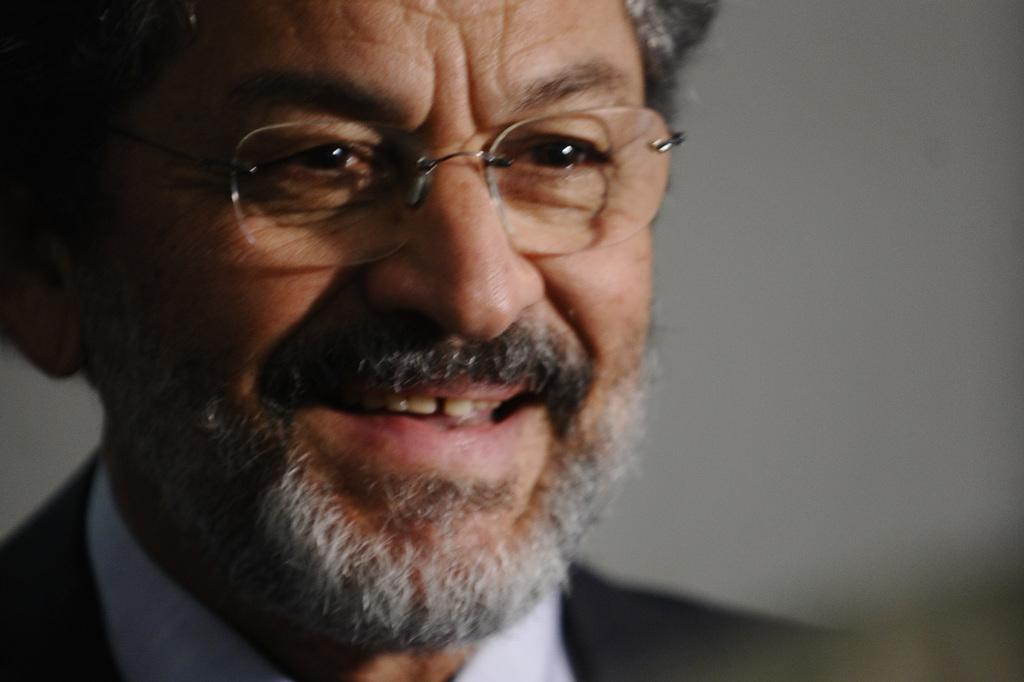Who is the main subject in the image? There is an old man in the image. What is the old man wearing? The old man is wearing a black suit and a white shirt. What expression does the old man have? The old man is smiling. What accessory is the old man wearing? The old man is wearing glasses. What type of loss can be seen in the image? There is no loss present in the image; it features an old man with a smile on his face. What type of rod can be seen in the image? There is no rod present in the image. 